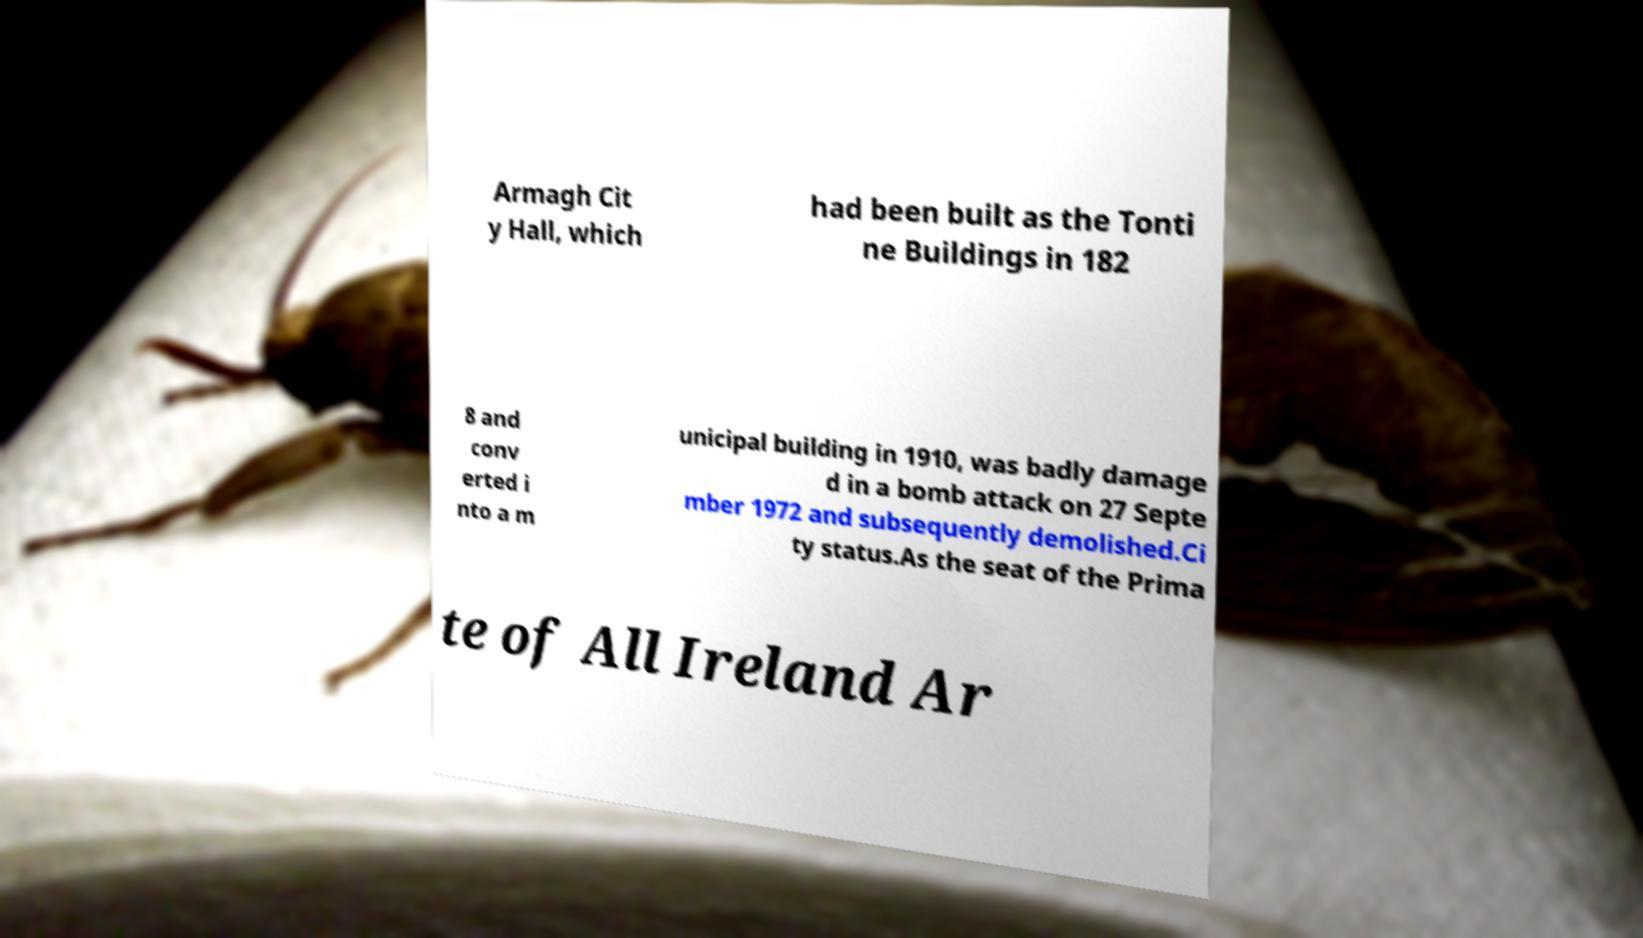Could you assist in decoding the text presented in this image and type it out clearly? Armagh Cit y Hall, which had been built as the Tonti ne Buildings in 182 8 and conv erted i nto a m unicipal building in 1910, was badly damage d in a bomb attack on 27 Septe mber 1972 and subsequently demolished.Ci ty status.As the seat of the Prima te of All Ireland Ar 